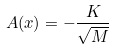Convert formula to latex. <formula><loc_0><loc_0><loc_500><loc_500>A ( x ) = - \frac { K } { \sqrt { M } }</formula> 